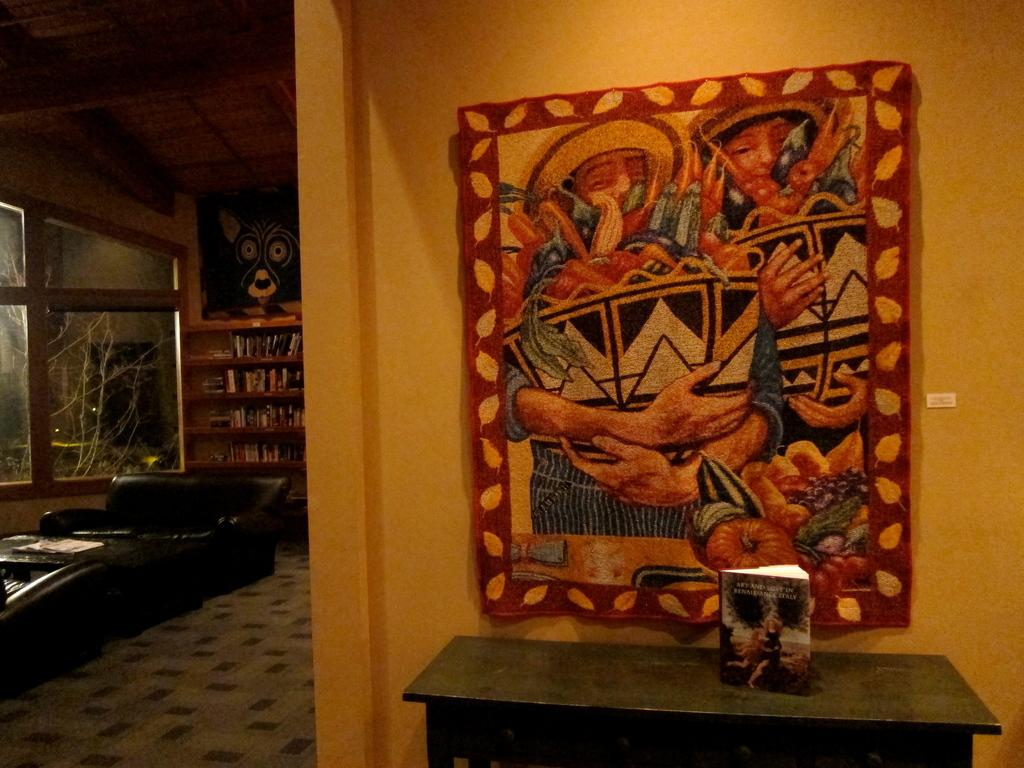What type of furniture is in the room? There is a sofa, a cupboard, and a table in the room. Can you describe the seating arrangement in the room? The sofa provides seating in the room. What type of storage furniture is in the room? There is a cupboard in the room for storage. What surface is available for placing objects in the room? There is a table in the room for placing objects. How much payment is required to use the sofa in the image? There is no payment required to use the sofa in the image, as it is a piece of furniture in a room. 